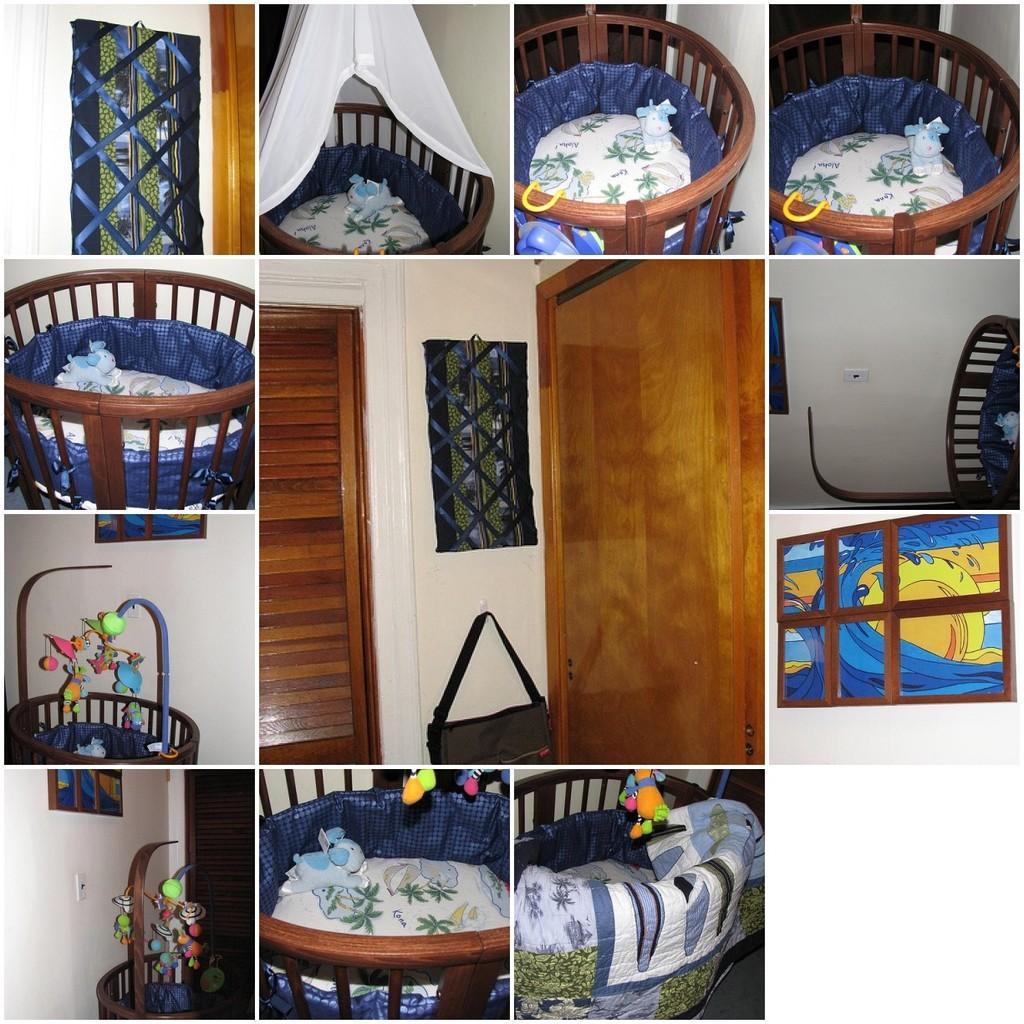What type of visual arrangement is present in the image? The image contains a collage of pictures. What specific items can be seen in the collage? Some pictures in the collage show a baby's bed, and there is a picture of a door. Are there any objects hanging on the wall in the image? Yes, there is a bag hanging on the wall in the image. What type of oatmeal is being served in the image? There is no oatmeal present in the image; it contains a collage of pictures, a baby's bed, a door, and a bag hanging on the wall. 